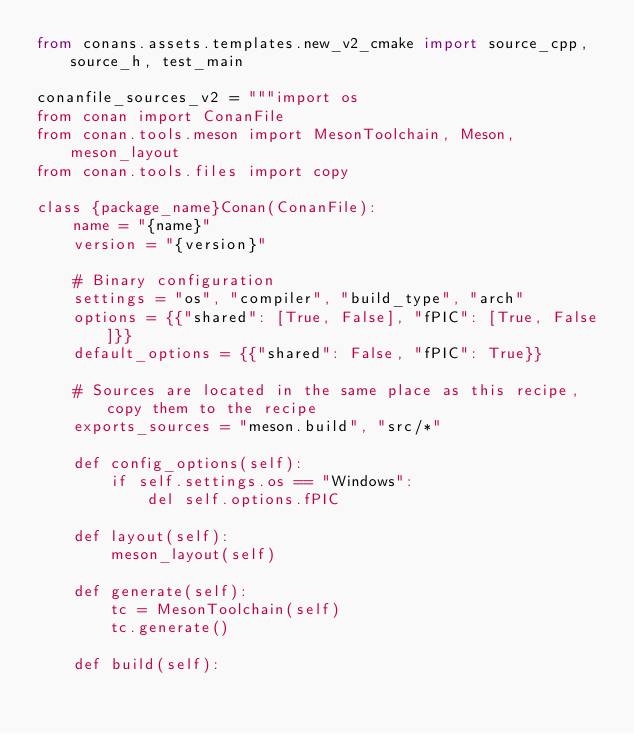Convert code to text. <code><loc_0><loc_0><loc_500><loc_500><_Python_>from conans.assets.templates.new_v2_cmake import source_cpp, source_h, test_main

conanfile_sources_v2 = """import os
from conan import ConanFile
from conan.tools.meson import MesonToolchain, Meson, meson_layout
from conan.tools.files import copy

class {package_name}Conan(ConanFile):
    name = "{name}"
    version = "{version}"

    # Binary configuration
    settings = "os", "compiler", "build_type", "arch"
    options = {{"shared": [True, False], "fPIC": [True, False]}}
    default_options = {{"shared": False, "fPIC": True}}

    # Sources are located in the same place as this recipe, copy them to the recipe
    exports_sources = "meson.build", "src/*"

    def config_options(self):
        if self.settings.os == "Windows":
            del self.options.fPIC

    def layout(self):
        meson_layout(self)

    def generate(self):
        tc = MesonToolchain(self)
        tc.generate()

    def build(self):</code> 